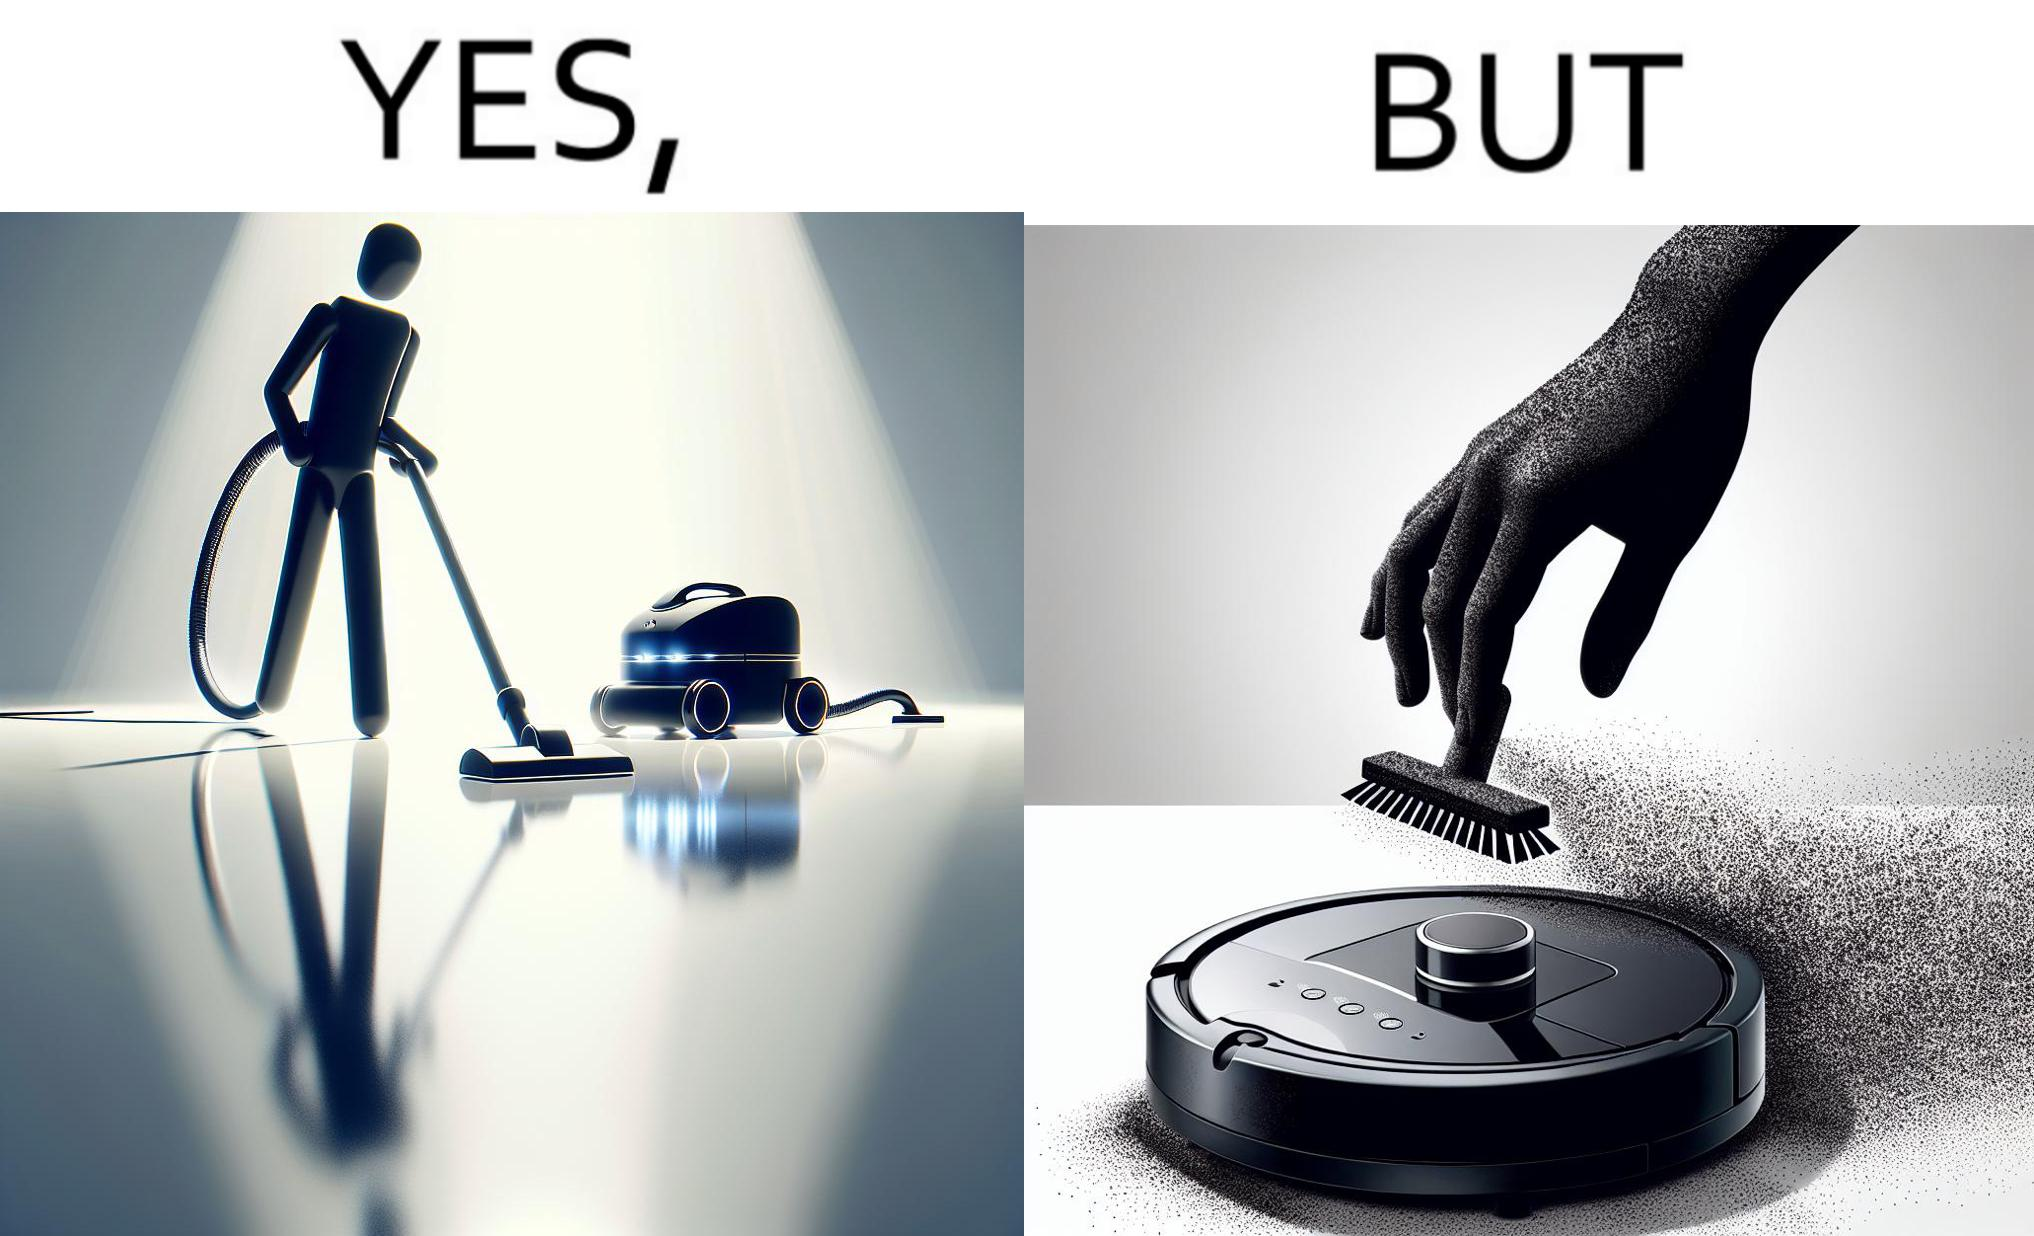Is this a satirical image? Yes, this image is satirical. 